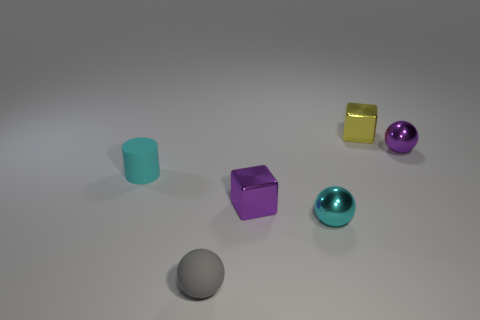Which of these objects is the largest? The largest object appears to be the yellow cube, standing out with its bright color and pronounced edges, in contrast to the smoother spheres and cylinder. 